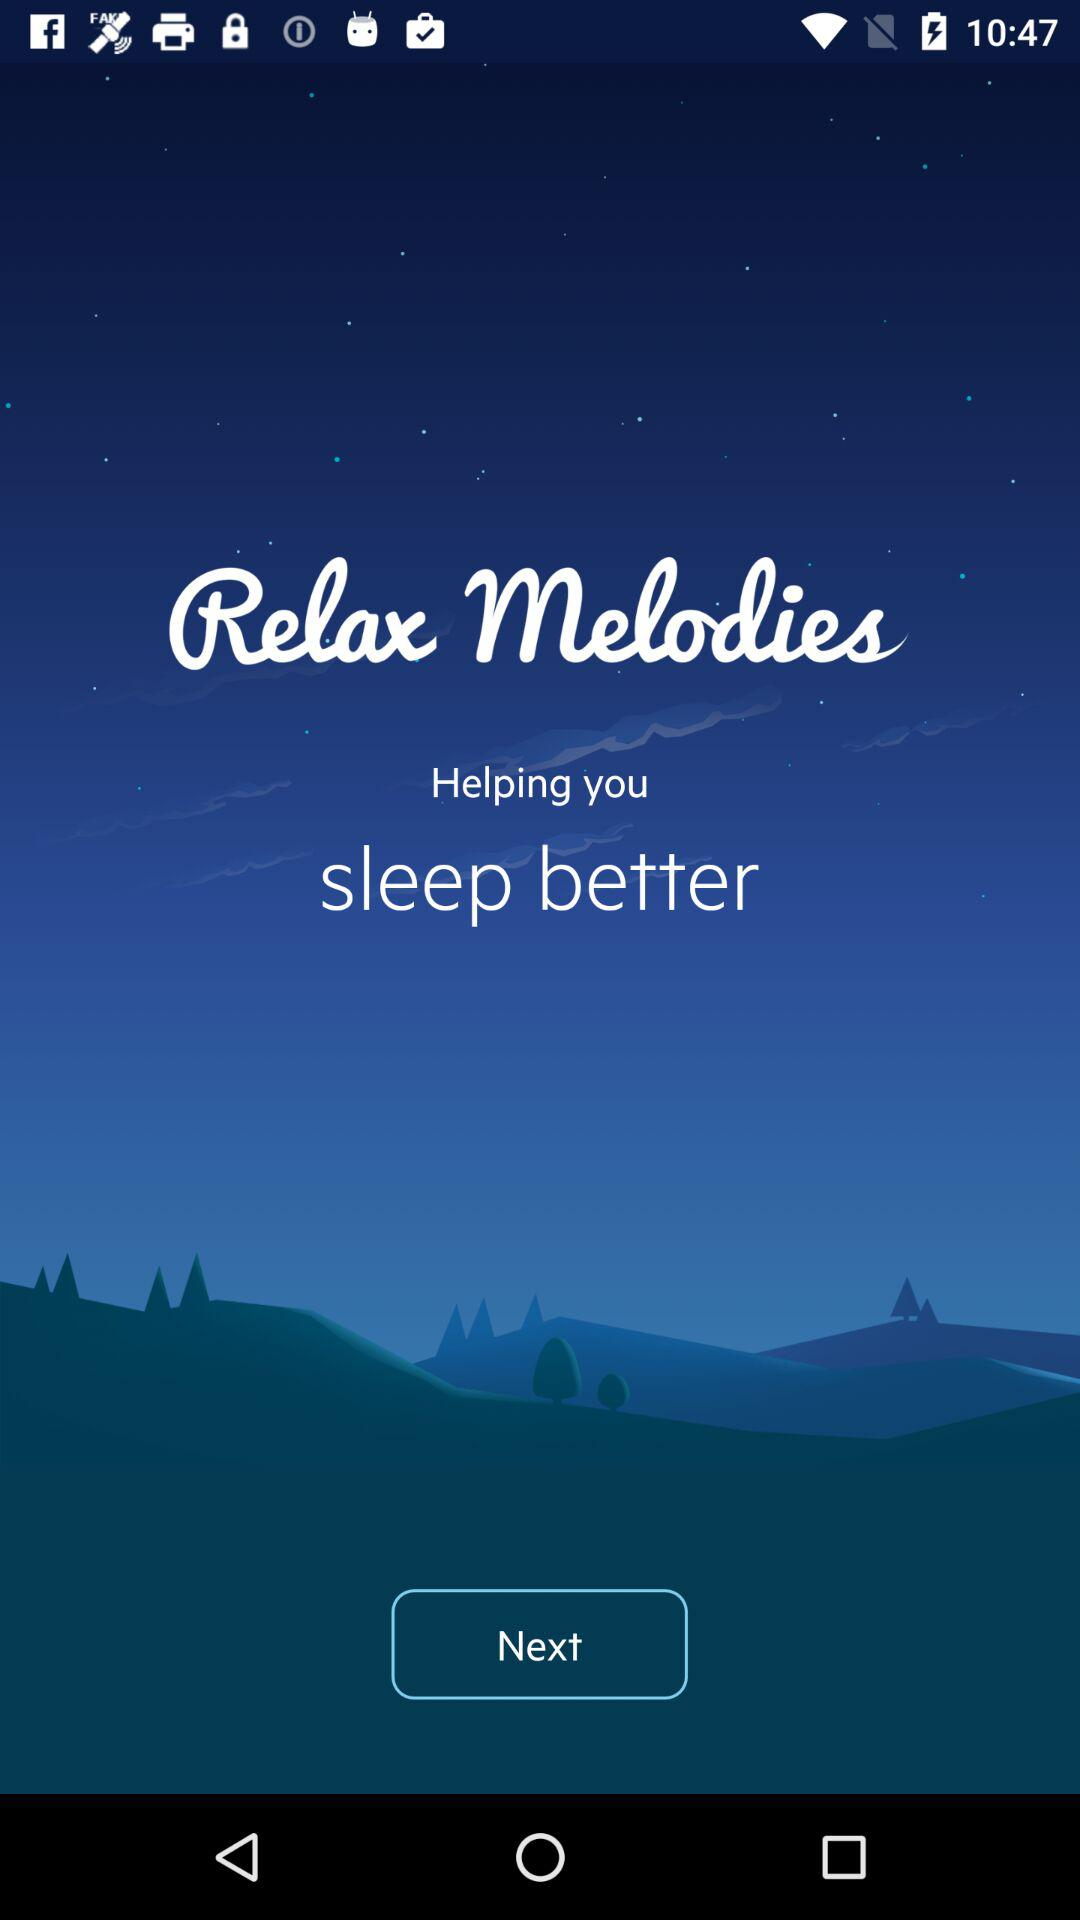What is the name of the application? The application name is "Relax Melodies". 